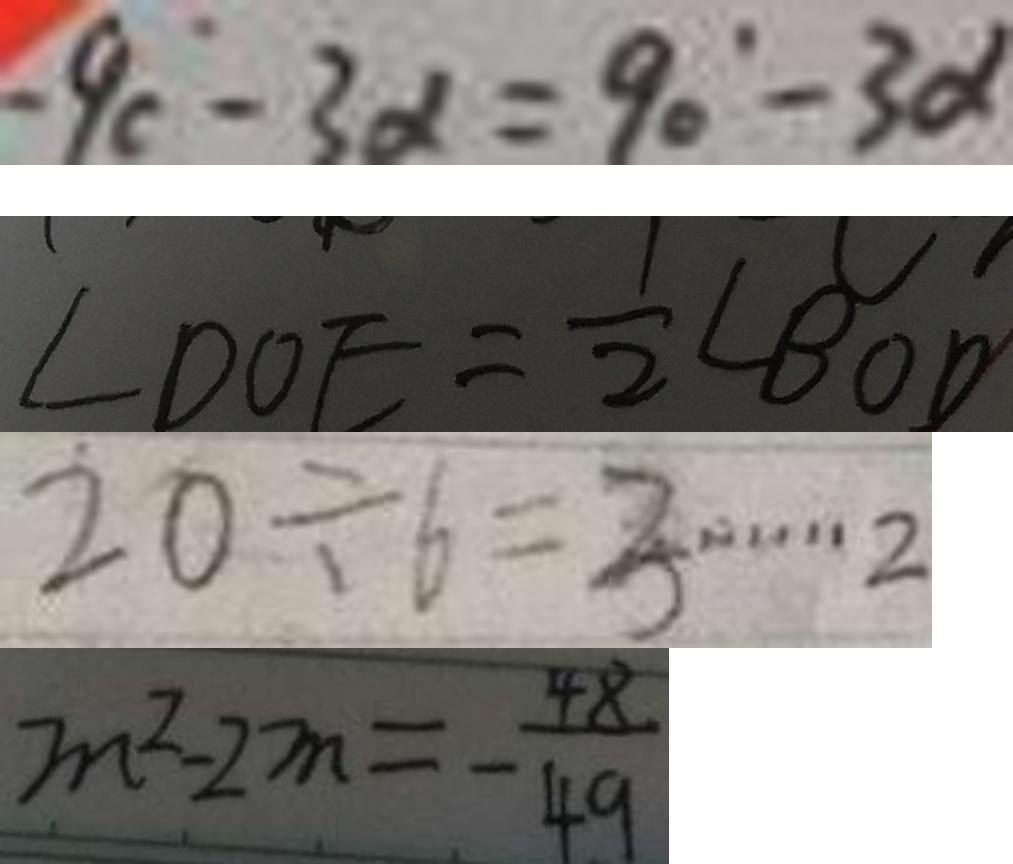Convert formula to latex. <formula><loc_0><loc_0><loc_500><loc_500>- 9 c - 3 \alpha = 9 0 ^ { \circ } - 3 \alpha 
 \angle D O E = \frac { 1 } { 2 } \angle B O D 
 2 0 \div 6 = 3 \cdots 2 
 m ^ { 2 } - 2 m = - \frac { 4 8 } { 4 9 }</formula> 